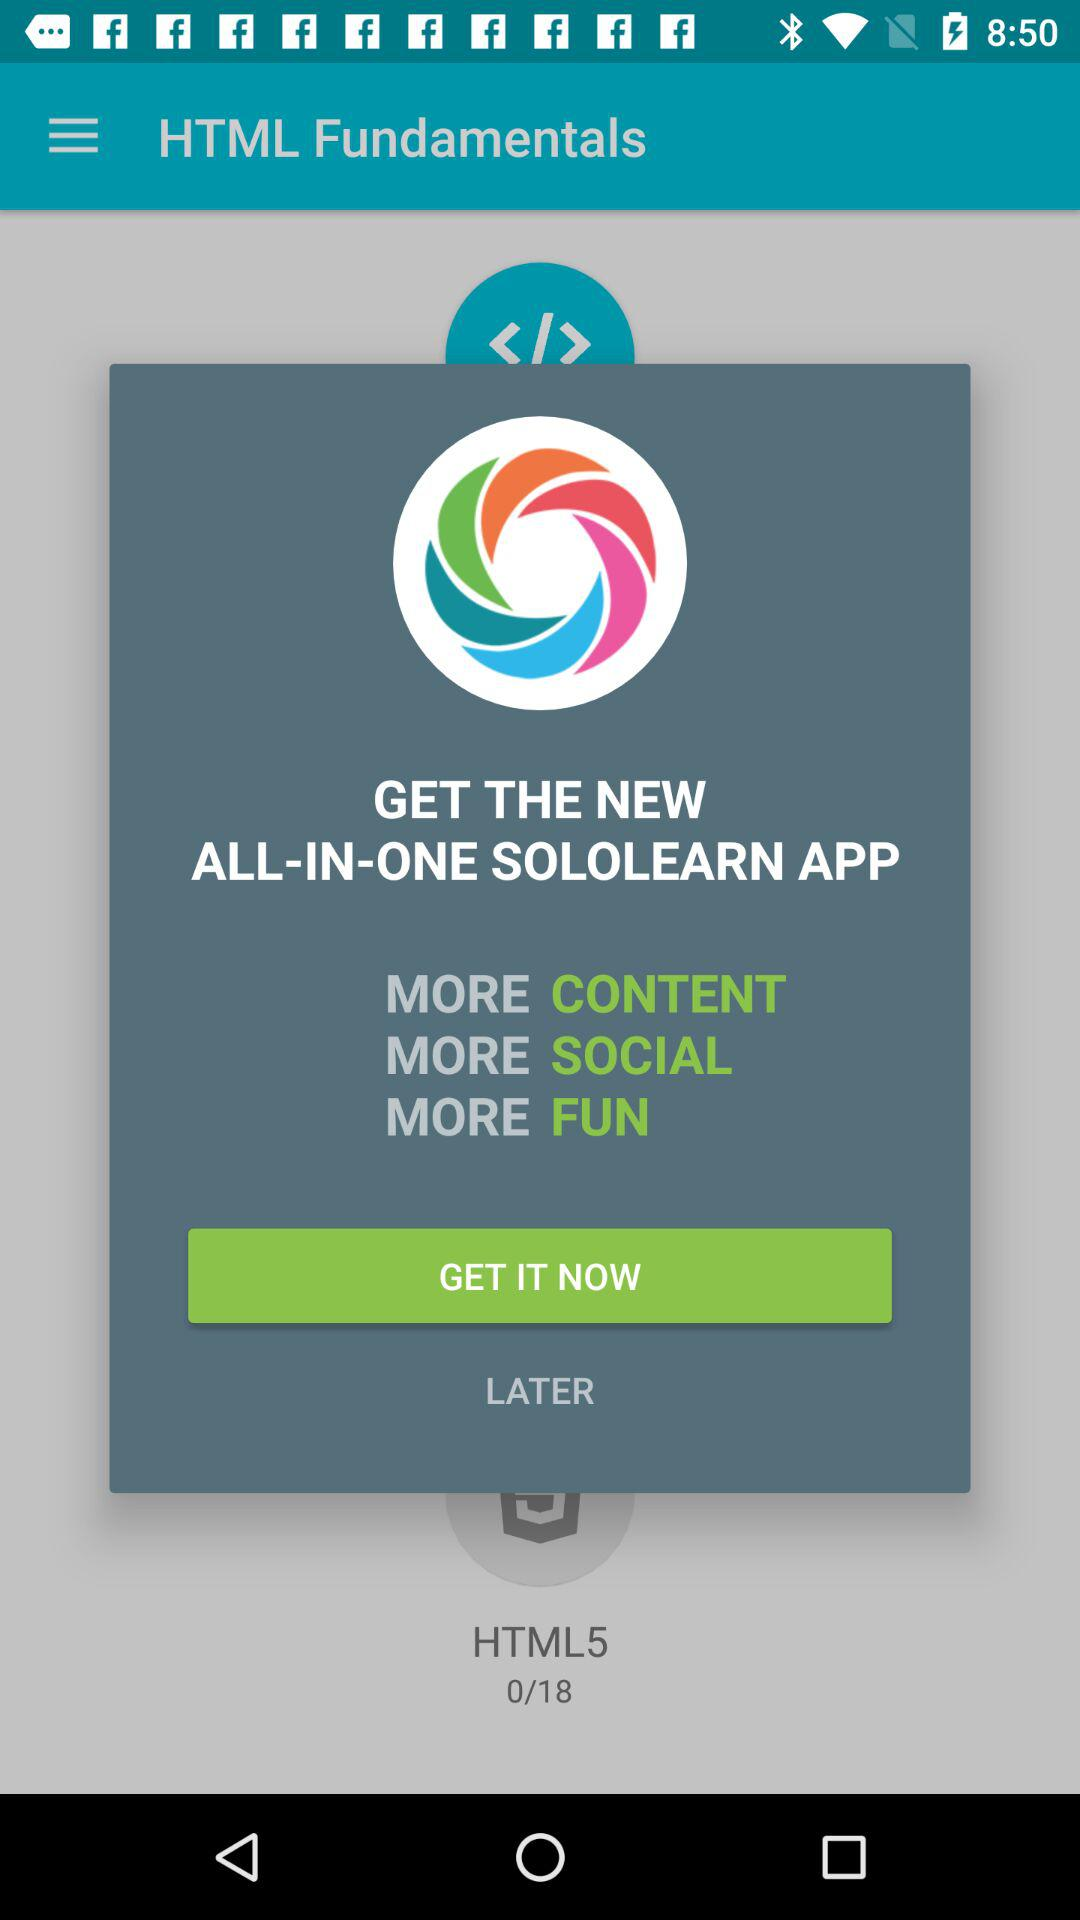How many more lessons do I have to complete?
Answer the question using a single word or phrase. 18 